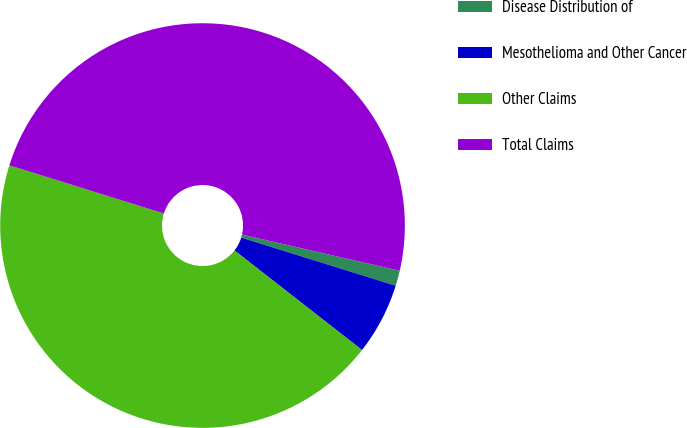Convert chart. <chart><loc_0><loc_0><loc_500><loc_500><pie_chart><fcel>Disease Distribution of<fcel>Mesothelioma and Other Cancer<fcel>Other Claims<fcel>Total Claims<nl><fcel>1.22%<fcel>5.74%<fcel>44.26%<fcel>48.78%<nl></chart> 